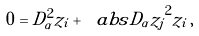Convert formula to latex. <formula><loc_0><loc_0><loc_500><loc_500>0 = D _ { \alpha } ^ { 2 } z _ { i } + \ a b s { D _ { \alpha } z _ { j } } ^ { 2 } z _ { i } \, ,</formula> 